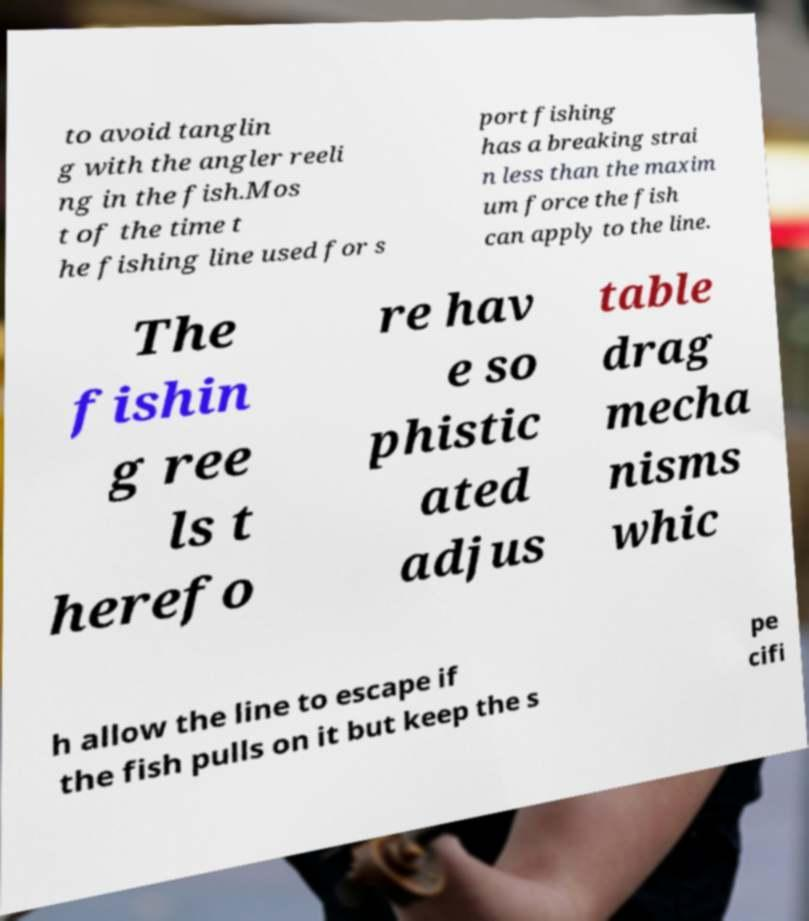Please read and relay the text visible in this image. What does it say? to avoid tanglin g with the angler reeli ng in the fish.Mos t of the time t he fishing line used for s port fishing has a breaking strai n less than the maxim um force the fish can apply to the line. The fishin g ree ls t herefo re hav e so phistic ated adjus table drag mecha nisms whic h allow the line to escape if the fish pulls on it but keep the s pe cifi 